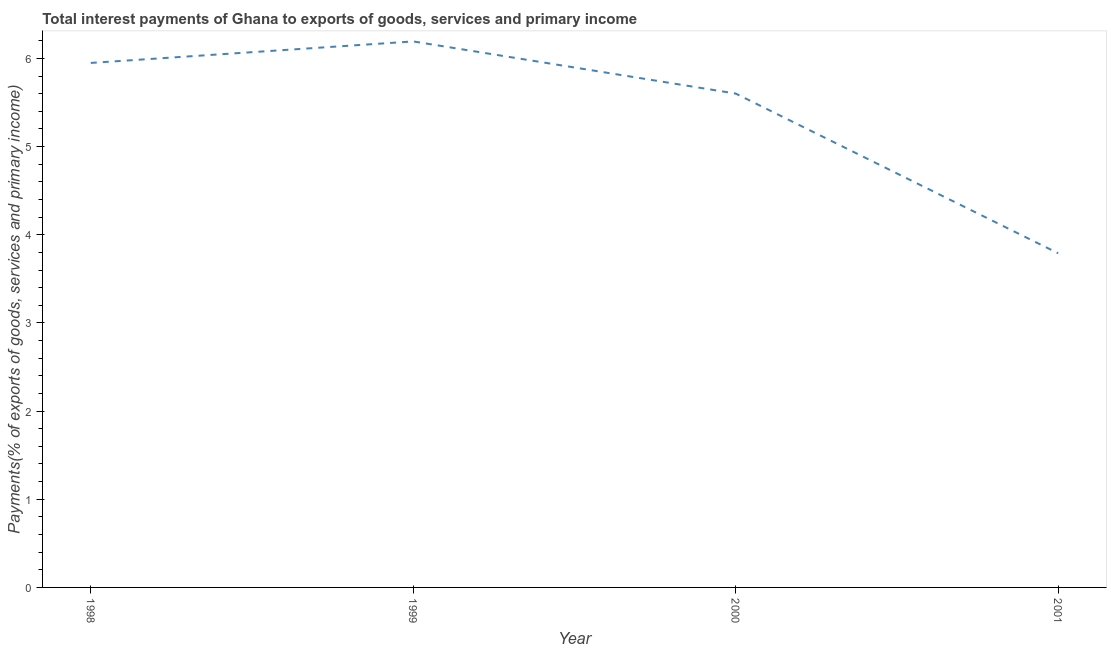What is the total interest payments on external debt in 2001?
Keep it short and to the point. 3.79. Across all years, what is the maximum total interest payments on external debt?
Give a very brief answer. 6.19. Across all years, what is the minimum total interest payments on external debt?
Keep it short and to the point. 3.79. In which year was the total interest payments on external debt maximum?
Keep it short and to the point. 1999. In which year was the total interest payments on external debt minimum?
Keep it short and to the point. 2001. What is the sum of the total interest payments on external debt?
Offer a terse response. 21.53. What is the difference between the total interest payments on external debt in 1998 and 2001?
Your answer should be compact. 2.16. What is the average total interest payments on external debt per year?
Keep it short and to the point. 5.38. What is the median total interest payments on external debt?
Give a very brief answer. 5.78. Do a majority of the years between 2001 and 2000 (inclusive) have total interest payments on external debt greater than 5.2 %?
Your response must be concise. No. What is the ratio of the total interest payments on external debt in 1999 to that in 2000?
Make the answer very short. 1.11. What is the difference between the highest and the second highest total interest payments on external debt?
Your answer should be compact. 0.24. Is the sum of the total interest payments on external debt in 1999 and 2001 greater than the maximum total interest payments on external debt across all years?
Keep it short and to the point. Yes. What is the difference between the highest and the lowest total interest payments on external debt?
Give a very brief answer. 2.4. What is the difference between two consecutive major ticks on the Y-axis?
Ensure brevity in your answer.  1. Are the values on the major ticks of Y-axis written in scientific E-notation?
Offer a terse response. No. Does the graph contain any zero values?
Your response must be concise. No. What is the title of the graph?
Make the answer very short. Total interest payments of Ghana to exports of goods, services and primary income. What is the label or title of the Y-axis?
Give a very brief answer. Payments(% of exports of goods, services and primary income). What is the Payments(% of exports of goods, services and primary income) of 1998?
Your answer should be compact. 5.95. What is the Payments(% of exports of goods, services and primary income) of 1999?
Provide a succinct answer. 6.19. What is the Payments(% of exports of goods, services and primary income) of 2000?
Your response must be concise. 5.6. What is the Payments(% of exports of goods, services and primary income) of 2001?
Provide a succinct answer. 3.79. What is the difference between the Payments(% of exports of goods, services and primary income) in 1998 and 1999?
Your response must be concise. -0.24. What is the difference between the Payments(% of exports of goods, services and primary income) in 1998 and 2000?
Your answer should be very brief. 0.35. What is the difference between the Payments(% of exports of goods, services and primary income) in 1998 and 2001?
Make the answer very short. 2.16. What is the difference between the Payments(% of exports of goods, services and primary income) in 1999 and 2000?
Provide a short and direct response. 0.59. What is the difference between the Payments(% of exports of goods, services and primary income) in 1999 and 2001?
Your answer should be compact. 2.4. What is the difference between the Payments(% of exports of goods, services and primary income) in 2000 and 2001?
Ensure brevity in your answer.  1.81. What is the ratio of the Payments(% of exports of goods, services and primary income) in 1998 to that in 2000?
Your response must be concise. 1.06. What is the ratio of the Payments(% of exports of goods, services and primary income) in 1998 to that in 2001?
Make the answer very short. 1.57. What is the ratio of the Payments(% of exports of goods, services and primary income) in 1999 to that in 2000?
Make the answer very short. 1.11. What is the ratio of the Payments(% of exports of goods, services and primary income) in 1999 to that in 2001?
Ensure brevity in your answer.  1.63. What is the ratio of the Payments(% of exports of goods, services and primary income) in 2000 to that in 2001?
Provide a short and direct response. 1.48. 